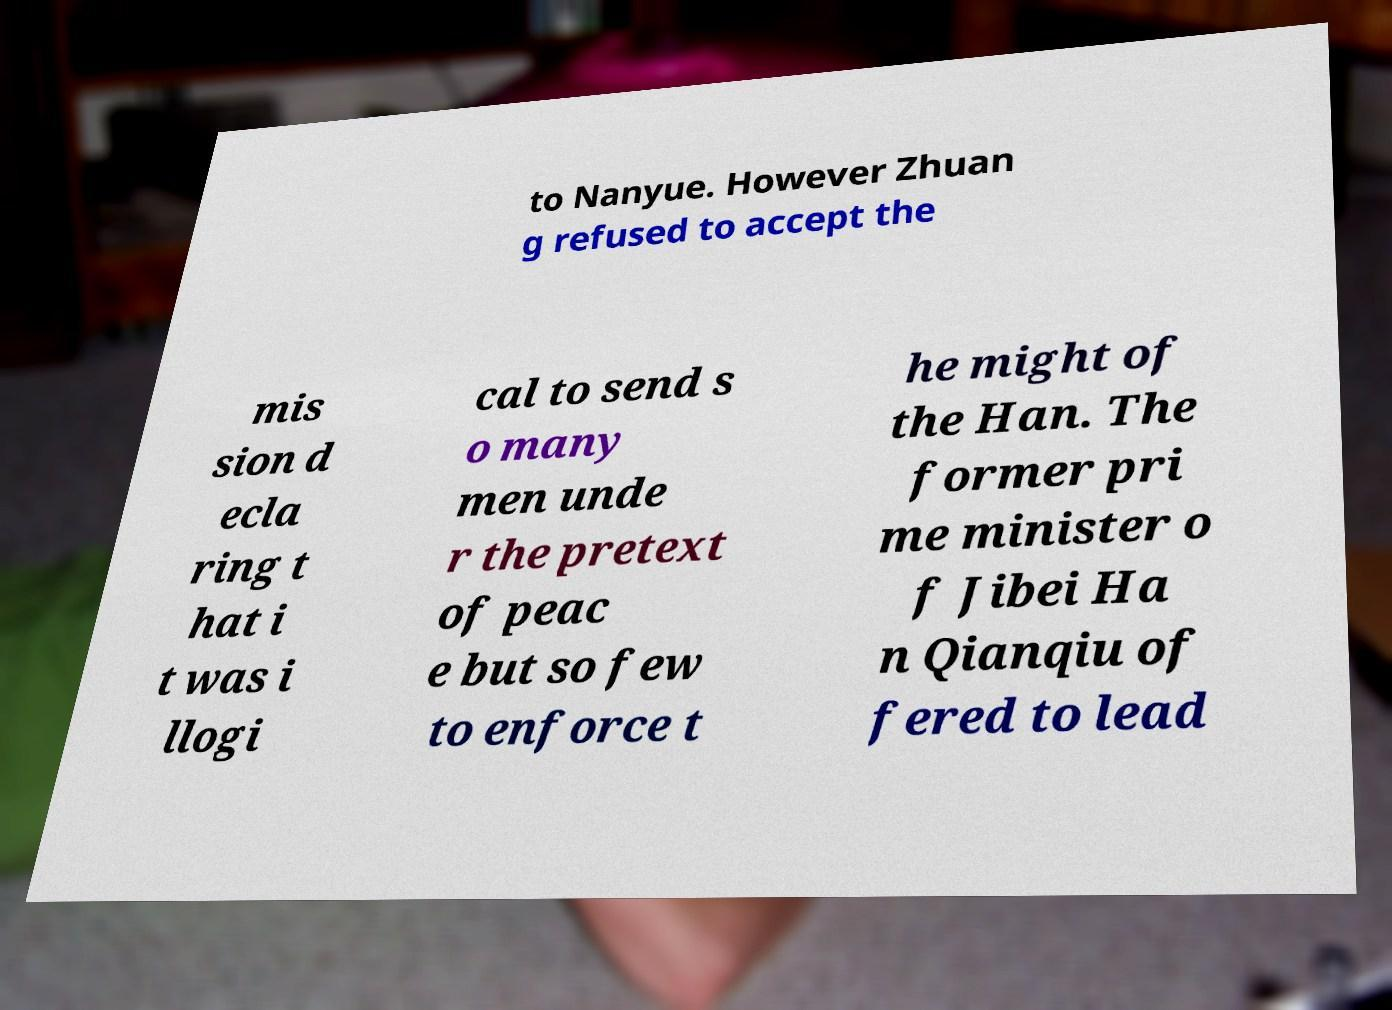Can you read and provide the text displayed in the image?This photo seems to have some interesting text. Can you extract and type it out for me? to Nanyue. However Zhuan g refused to accept the mis sion d ecla ring t hat i t was i llogi cal to send s o many men unde r the pretext of peac e but so few to enforce t he might of the Han. The former pri me minister o f Jibei Ha n Qianqiu of fered to lead 